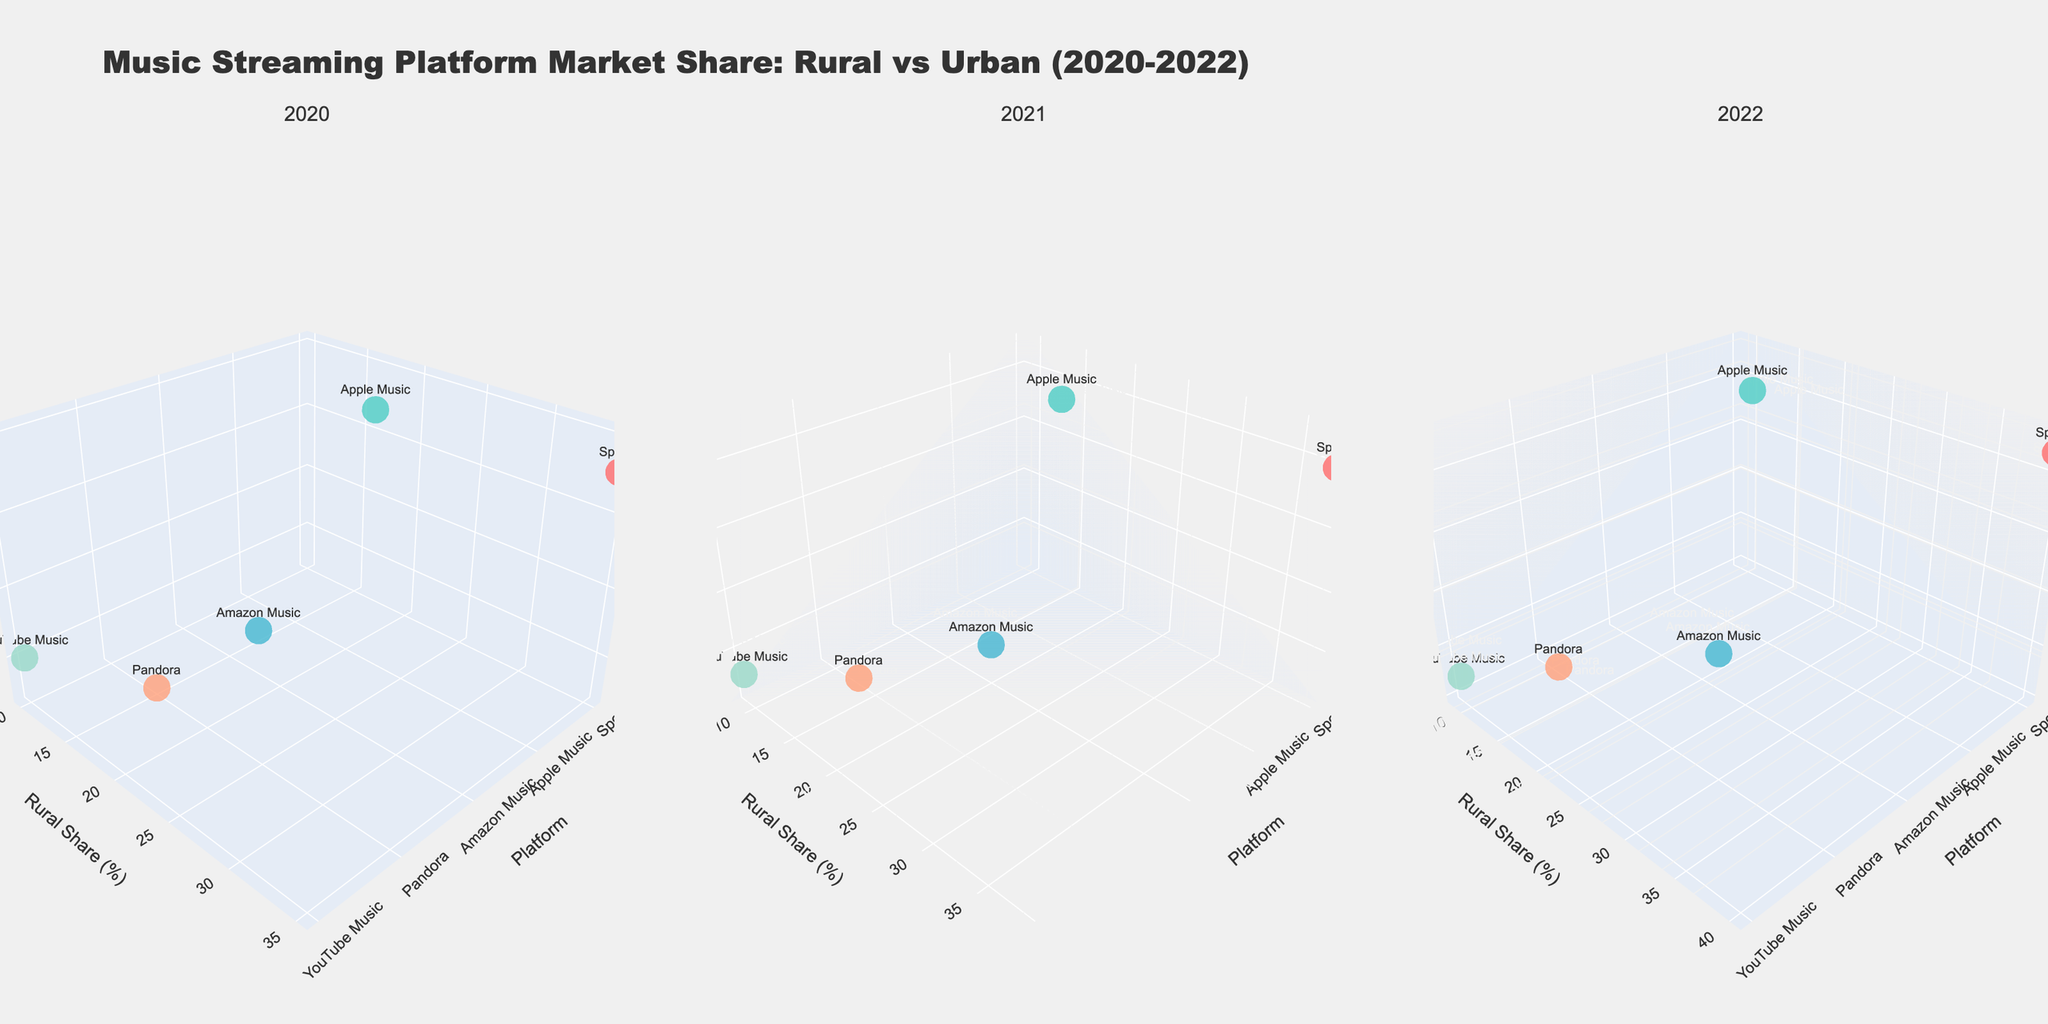What year shows Spotify with the highest rural share? In the figure, we look at each year's subplot to find the highest rural share for Spotify. By examining the 'Rural_Share' axis for Spotify in each year, we see that the highest value is in the subplot for 2022.
Answer: 2022 What is the urban share difference between Apple Music and Spotify in 2021? First, identify the urban share values for Apple Music and Spotify in 2021 from the 2021 subplot. Apple Music has 32%, and Spotify has 30%. The difference is 32% - 30% = 2%.
Answer: 2% Which platform has the lowest urban share in 2020? In the 2020 subplot, check the data points' 'Urban_Share' values. The platform with the lowest value is Pandora, with an urban share of 12%.
Answer: Pandora Between 2020 and 2022, did Amazon Music's rural share increase or decrease? Compare the rural share for Amazon Music across the 2020, 2021, and 2022 subplots. It was 18% in 2020, 20% in 2021, and 22% in 2022, indicating an increase over the three years.
Answer: Increase Did YouTube Music’s urban share increase by 2022 compared to 2020? Look at YouTube Music’s urban share in the 2020 and 2022 subplots. It was 15% in 2020 and 12% in 2022. Since 12% is less than 15%, the urban share decreased.
Answer: No What is the average rural share of Spotify from 2020 to 2022? Extract Spotify's rural shares for 2020, 2021, and 2022: 35%, 38%, and 40%. Calculate the average: (35 + 38 + 40) / 3 = 113 / 3 ≈ 37.67%.
Answer: 37.67% In which year does YouTube Music have its lowest rural share? By reviewing the rural shares for YouTube Music in each year: 10% in 2020, 9% in 2021, and 9% in 2022. The lowest share is 9%, occurring in both 2021 and 2022.
Answer: 2021 and 2022 Which platform saw the greatest increase in urban share from 2020 to 2022? Compare the urban shares for all platforms from 2020 to 2022. Spotify had 28% to 32% (+4%), Apple Music had 30% to 33% (+3%), Amazon Music had 15% to 13% (-2%), Pandora had 12% to 10% (-2%), YouTube Music had 15% to 12% (-3%). Spotify’s increase of 4% is the highest.
Answer: Spotify 